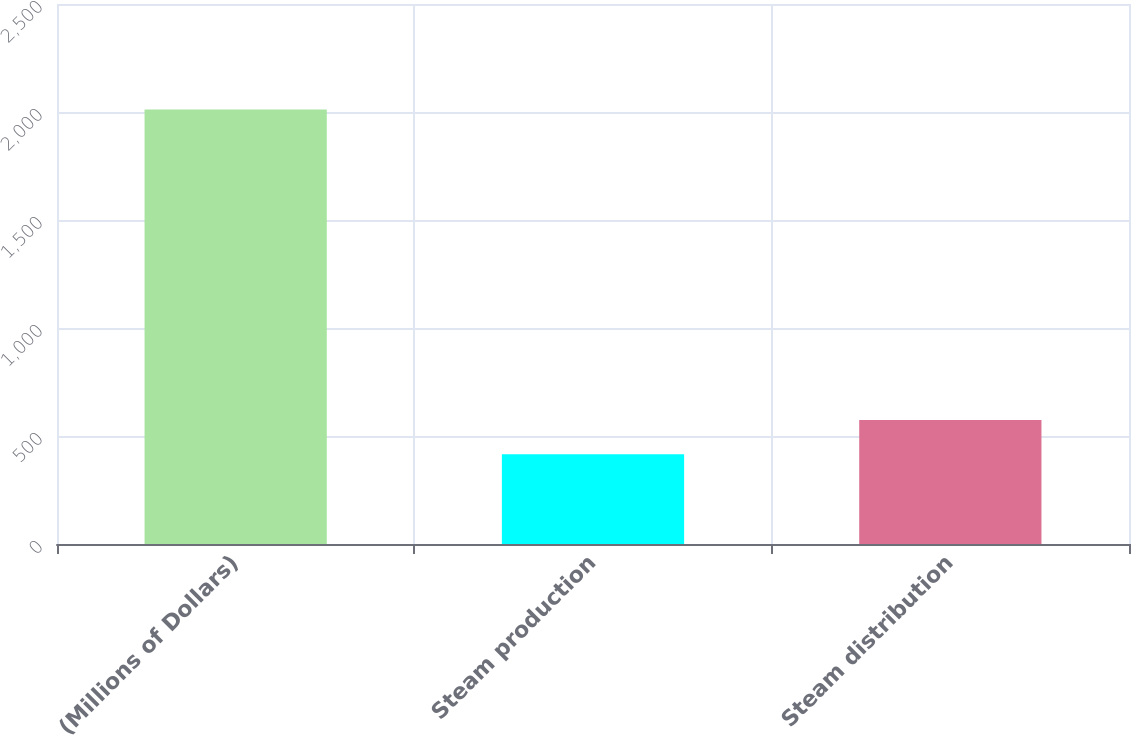<chart> <loc_0><loc_0><loc_500><loc_500><bar_chart><fcel>(Millions of Dollars)<fcel>Steam production<fcel>Steam distribution<nl><fcel>2011<fcel>415<fcel>574.6<nl></chart> 